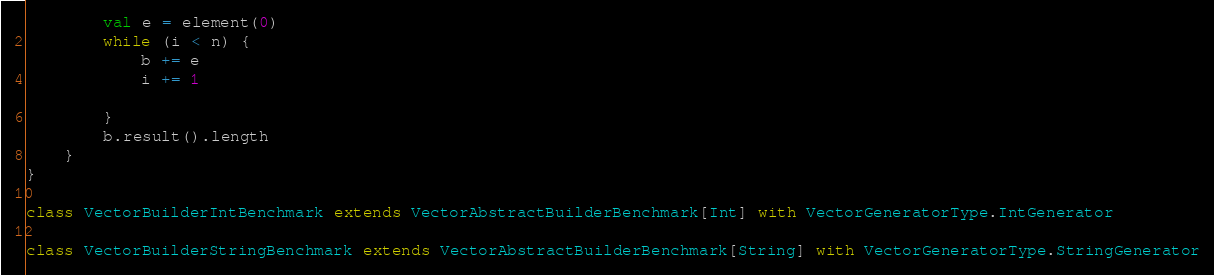Convert code to text. <code><loc_0><loc_0><loc_500><loc_500><_Scala_>        val e = element(0)
        while (i < n) {
            b += e
            i += 1

        }
        b.result().length
    }
}

class VectorBuilderIntBenchmark extends VectorAbstractBuilderBenchmark[Int] with VectorGeneratorType.IntGenerator

class VectorBuilderStringBenchmark extends VectorAbstractBuilderBenchmark[String] with VectorGeneratorType.StringGenerator</code> 